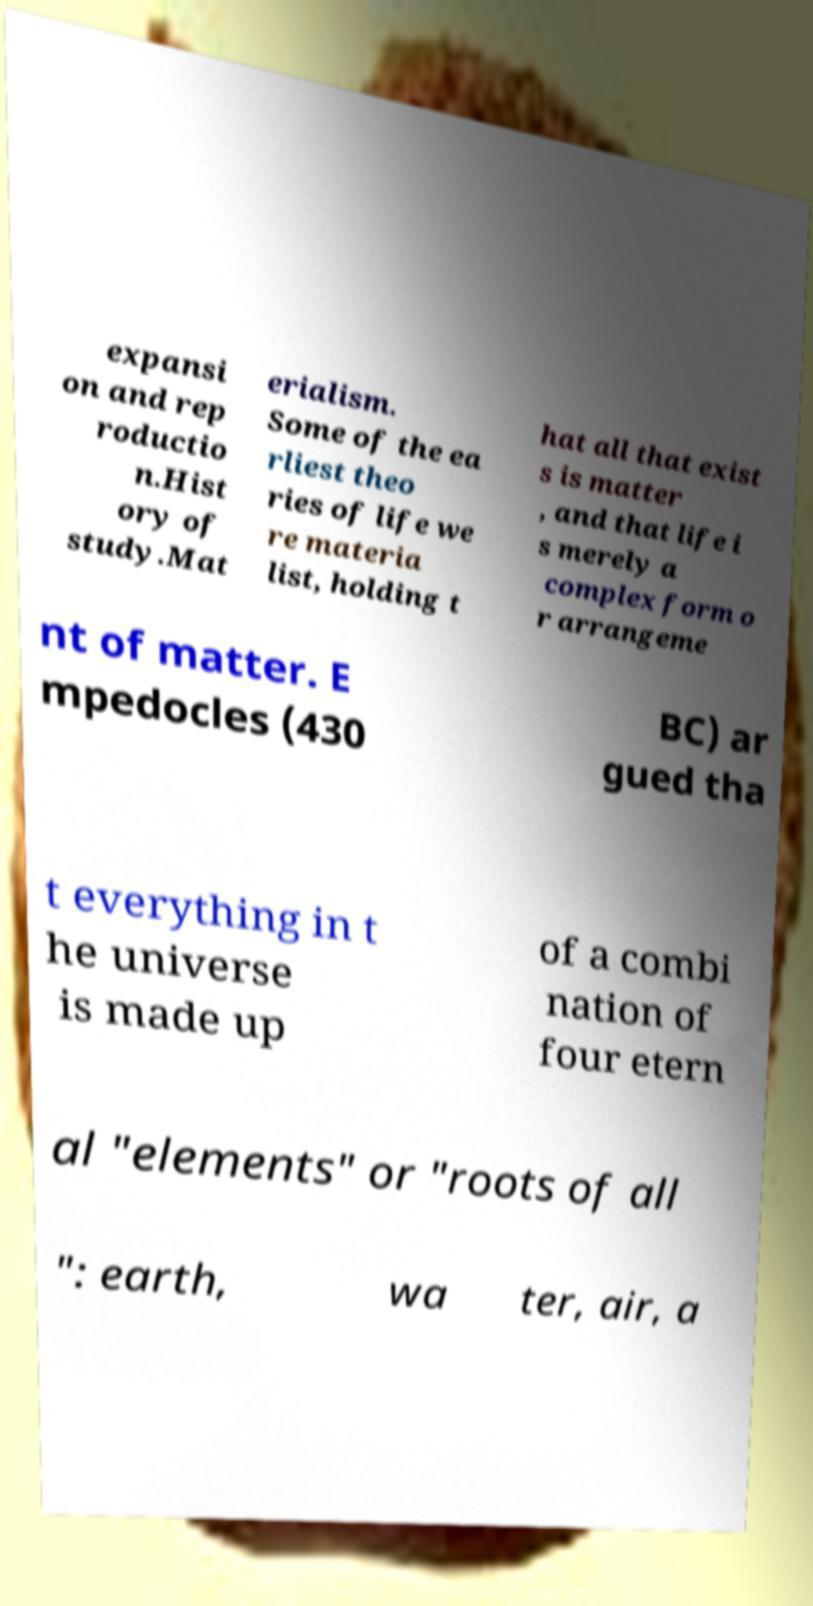Can you read and provide the text displayed in the image?This photo seems to have some interesting text. Can you extract and type it out for me? expansi on and rep roductio n.Hist ory of study.Mat erialism. Some of the ea rliest theo ries of life we re materia list, holding t hat all that exist s is matter , and that life i s merely a complex form o r arrangeme nt of matter. E mpedocles (430 BC) ar gued tha t everything in t he universe is made up of a combi nation of four etern al "elements" or "roots of all ": earth, wa ter, air, a 